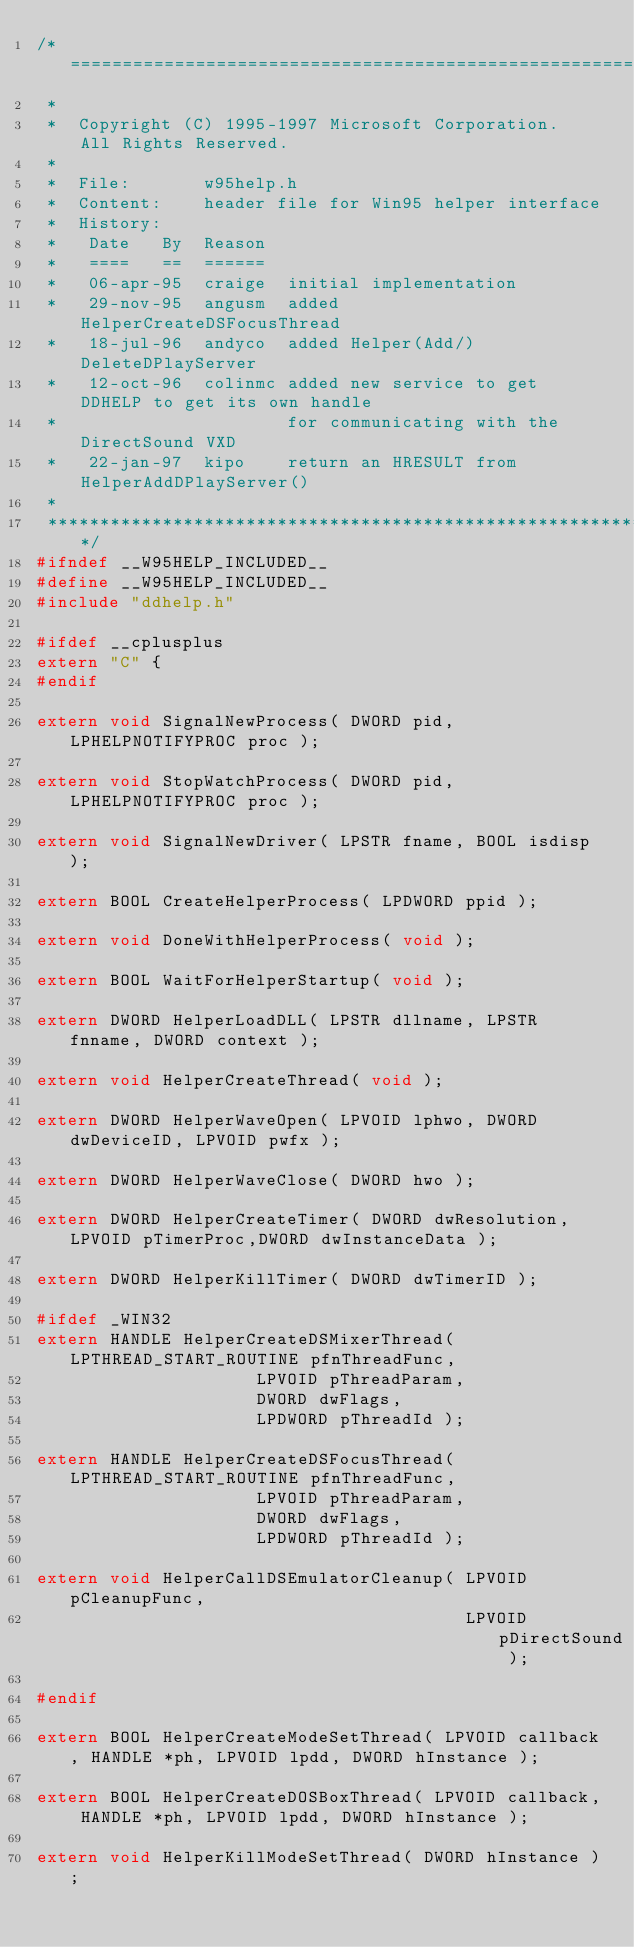Convert code to text. <code><loc_0><loc_0><loc_500><loc_500><_C_>/*==========================================================================
 *
 *  Copyright (C) 1995-1997 Microsoft Corporation.  All Rights Reserved.
 *
 *  File:       w95help.h
 *  Content:	header file for Win95 helper interface
 *  History:
 *   Date	By	Reason
 *   ====	==	======
 *   06-apr-95	craige	initial implementation
 *   29-nov-95  angusm  added HelperCreateDSFocusThread
 *   18-jul-96	andyco	added Helper(Add/)DeleteDPlayServer
 *   12-oct-96  colinmc added new service to get DDHELP to get its own handle
 *                      for communicating with the DirectSound VXD
 *   22-jan-97  kipo	return an HRESULT from HelperAddDPlayServer()
 *
 ***************************************************************************/
#ifndef __W95HELP_INCLUDED__
#define __W95HELP_INCLUDED__
#include "ddhelp.h"

#ifdef __cplusplus
extern "C" {
#endif

extern void SignalNewProcess( DWORD pid, LPHELPNOTIFYPROC proc );

extern void StopWatchProcess( DWORD pid, LPHELPNOTIFYPROC proc );

extern void SignalNewDriver( LPSTR fname, BOOL isdisp );

extern BOOL CreateHelperProcess( LPDWORD ppid );

extern void DoneWithHelperProcess( void );

extern BOOL WaitForHelperStartup( void );

extern DWORD HelperLoadDLL( LPSTR dllname, LPSTR fnname, DWORD context );

extern void HelperCreateThread( void );

extern DWORD HelperWaveOpen( LPVOID lphwo, DWORD dwDeviceID, LPVOID pwfx );

extern DWORD HelperWaveClose( DWORD hwo );

extern DWORD HelperCreateTimer( DWORD dwResolution,LPVOID pTimerProc,DWORD dwInstanceData );

extern DWORD HelperKillTimer( DWORD dwTimerID );

#ifdef _WIN32
extern HANDLE HelperCreateDSMixerThread( LPTHREAD_START_ROUTINE pfnThreadFunc,
					 LPVOID pThreadParam,
					 DWORD dwFlags,
					 LPDWORD pThreadId );

extern HANDLE HelperCreateDSFocusThread( LPTHREAD_START_ROUTINE pfnThreadFunc,
					 LPVOID pThreadParam,
					 DWORD dwFlags,
					 LPDWORD pThreadId );

extern void HelperCallDSEmulatorCleanup( LPVOID pCleanupFunc,
                                         LPVOID pDirectSound );

#endif

extern BOOL HelperCreateModeSetThread( LPVOID callback, HANDLE *ph, LPVOID lpdd, DWORD hInstance );

extern BOOL HelperCreateDOSBoxThread( LPVOID callback, HANDLE *ph, LPVOID lpdd, DWORD hInstance );

extern void HelperKillModeSetThread( DWORD hInstance );
</code> 